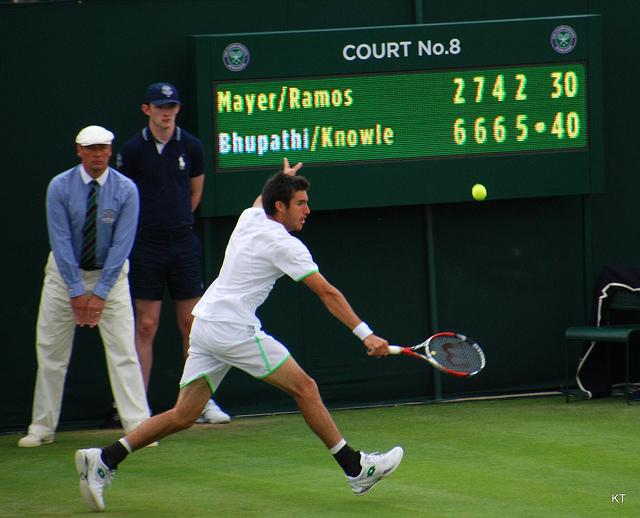Is the athlete professional?
Short answer required. Yes. How many persons are wearing hats?
Keep it brief. 2. What is the facial expression of the man?
Short answer required. Serious. What is he stretched out for?
Quick response, please. Hitting ball. 